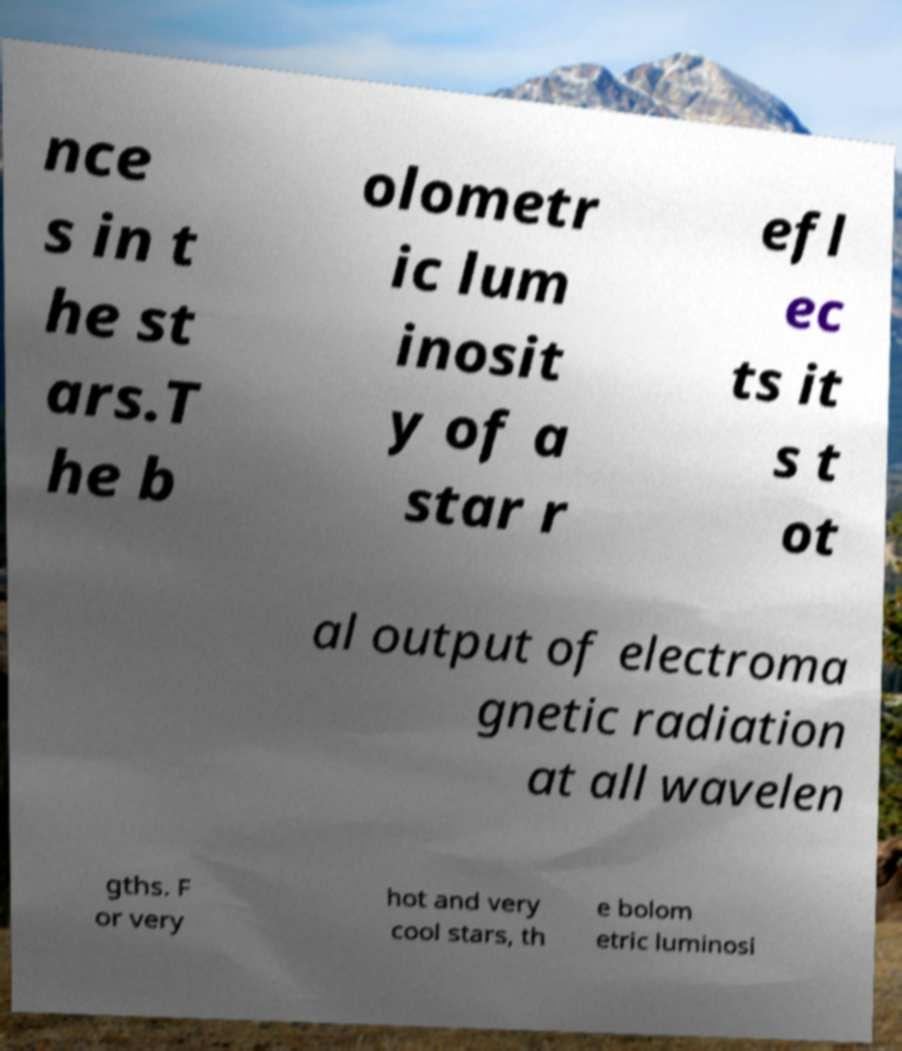For documentation purposes, I need the text within this image transcribed. Could you provide that? nce s in t he st ars.T he b olometr ic lum inosit y of a star r efl ec ts it s t ot al output of electroma gnetic radiation at all wavelen gths. F or very hot and very cool stars, th e bolom etric luminosi 